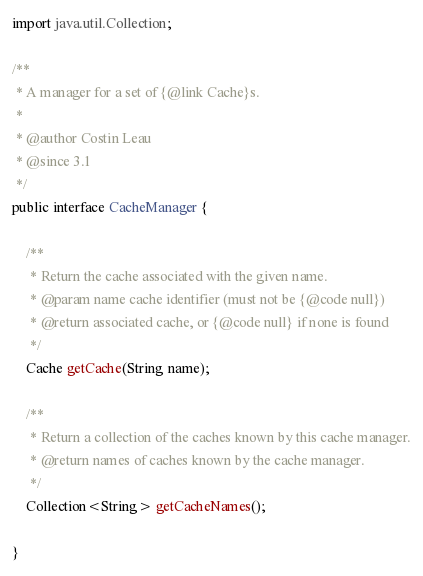Convert code to text. <code><loc_0><loc_0><loc_500><loc_500><_Java_>

import java.util.Collection;

/**
 * A manager for a set of {@link Cache}s.
 *
 * @author Costin Leau
 * @since 3.1
 */
public interface CacheManager {

    /**
     * Return the cache associated with the given name.
     * @param name cache identifier (must not be {@code null})
     * @return associated cache, or {@code null} if none is found
     */
    Cache getCache(String name);

    /**
     * Return a collection of the caches known by this cache manager.
     * @return names of caches known by the cache manager.
     */
    Collection<String> getCacheNames();

}
</code> 